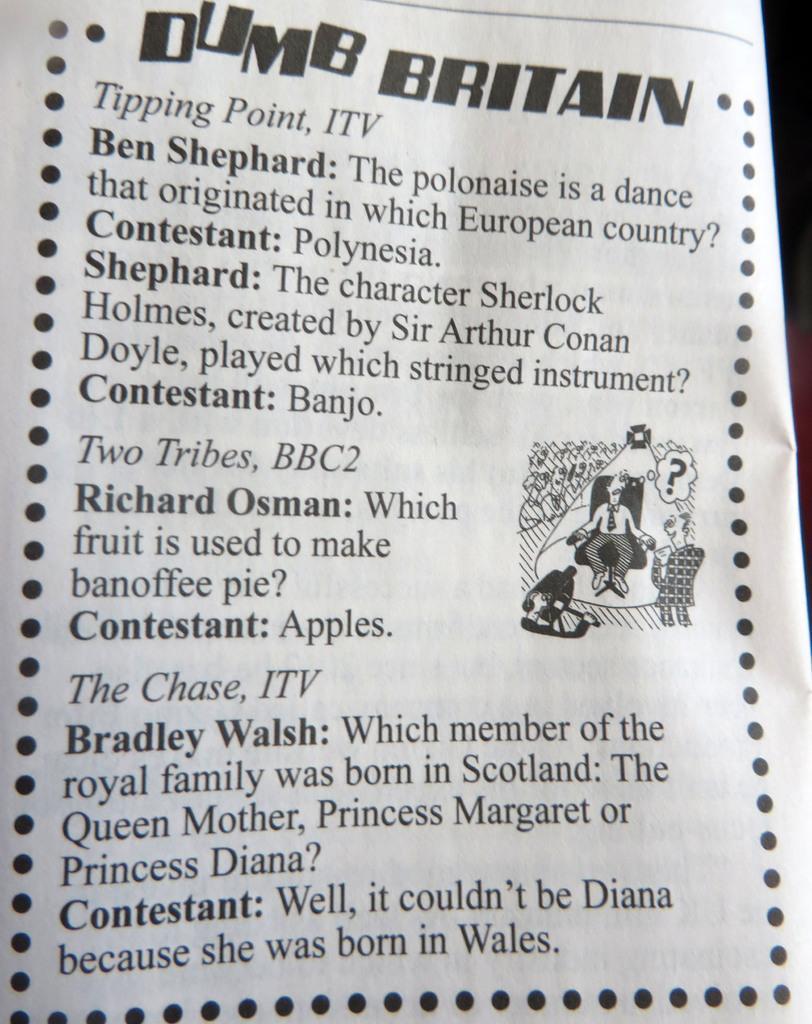Please provide a concise description of this image. In this image I can see a paper which is white in color and on it I can see few words written with black color and a sketch of a person sitting on a chair. I can see the black colored background. 